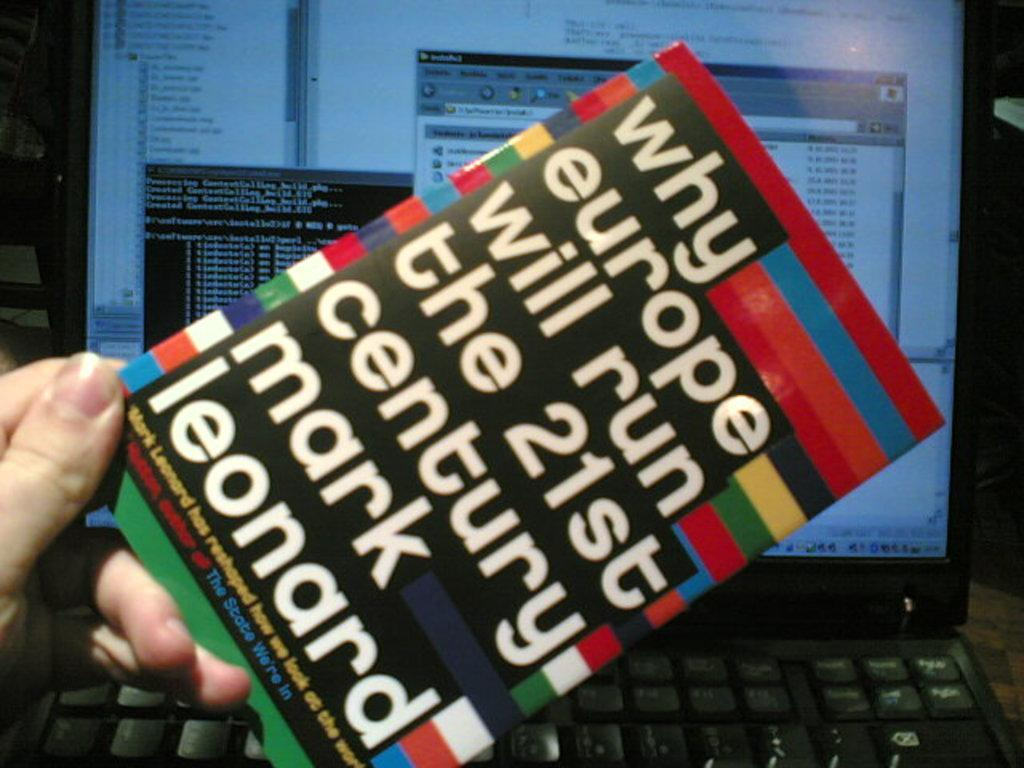<image>
Share a concise interpretation of the image provided. Person holding a book that says "Why Europe Will Run The 21st Century". 